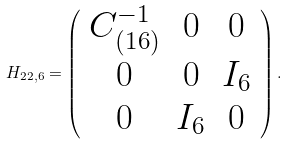Convert formula to latex. <formula><loc_0><loc_0><loc_500><loc_500>H _ { 2 2 , 6 } = \left ( \begin{array} { c c c } C ^ { - 1 } _ { ( 1 6 ) } & 0 & 0 \\ 0 & 0 & I _ { 6 } \\ 0 & I _ { 6 } & 0 \\ \end{array} \right ) .</formula> 